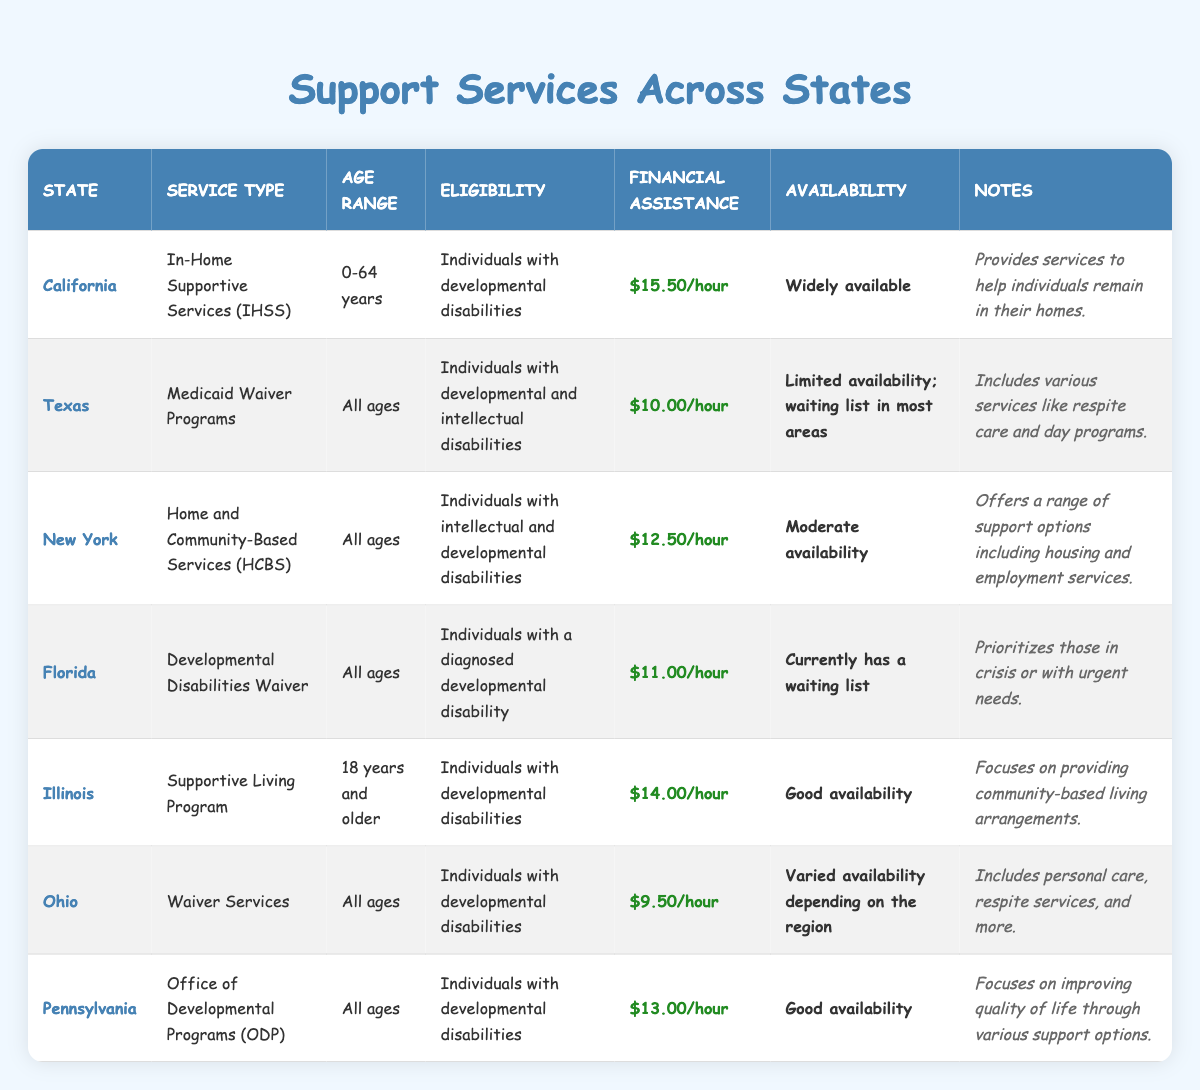What support service is provided in California? The table lists "In-Home Supportive Services (IHSS)" as the service type in California.
Answer: In-Home Supportive Services (IHSS) How much is the financial assistance offered by New York's support program? In the New York row, the financial assistance amount is shown as "$12.50/hour."
Answer: $12.50/hour Does Texas have programs for individuals with intellectual disabilities? The eligibility note for Texas states it includes "Individuals with developmental and intellectual disabilities," which confirms it offers such programs.
Answer: Yes Which state offers the highest financial assistance for support services? By comparing the financial assistance values, California offers the highest at "$15.50/hour."
Answer: $15.50/hour What is the age range for the Supportive Living Program in Illinois? The table specifies the age range for Illinois' Supportive Living Program as "18 years and older."
Answer: 18 years and older Which states have limited availability for their support services? By looking at the availability column, Texas and Florida are identified as having limited availability for their services.
Answer: Texas and Florida What is the difference in financial assistance between the service offered in Ohio and California? California provides "$15.50/hour" while Ohio offers "$9.50/hour." The difference is calculated as $15.50 - $9.50 = $6.00.
Answer: $6.00 Is there a waiting list for the support services in Illinois? The availability note for Illinois indicates "Good availability," suggesting there is no waiting list for services there.
Answer: No Which states do not have a waiting list for their support services? The states with "Good availability" and "Widely available" are Illinois, Pennsylvania, and California, meaning they do not have a waiting list.
Answer: Illinois, Pennsylvania, California What type of support service does Florida provide, and who is eligible? The service type is "Developmental Disabilities Waiver," and the eligibility is for "Individuals with a diagnosed developmental disability."
Answer: Developmental Disabilities Waiver; Individuals with a diagnosed developmental disability Which state has the most extensive age range for service eligibility? Looking at the eligibility section, Texas has "All ages," which means it applies to the widest range.
Answer: Texas 